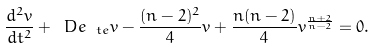<formula> <loc_0><loc_0><loc_500><loc_500>\frac { d ^ { 2 } v } { d t ^ { 2 } } + \ D e _ { \ t e } v - \frac { ( n - 2 ) ^ { 2 } } { 4 } v + \frac { n ( n - 2 ) } { 4 } v ^ { \frac { n + 2 } { n - 2 } } = 0 .</formula> 